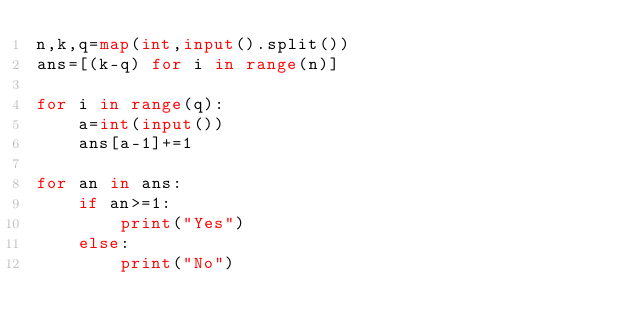Convert code to text. <code><loc_0><loc_0><loc_500><loc_500><_Python_>n,k,q=map(int,input().split())
ans=[(k-q) for i in range(n)]

for i in range(q):
    a=int(input())
    ans[a-1]+=1

for an in ans:
    if an>=1:
        print("Yes")
    else:
        print("No")
</code> 